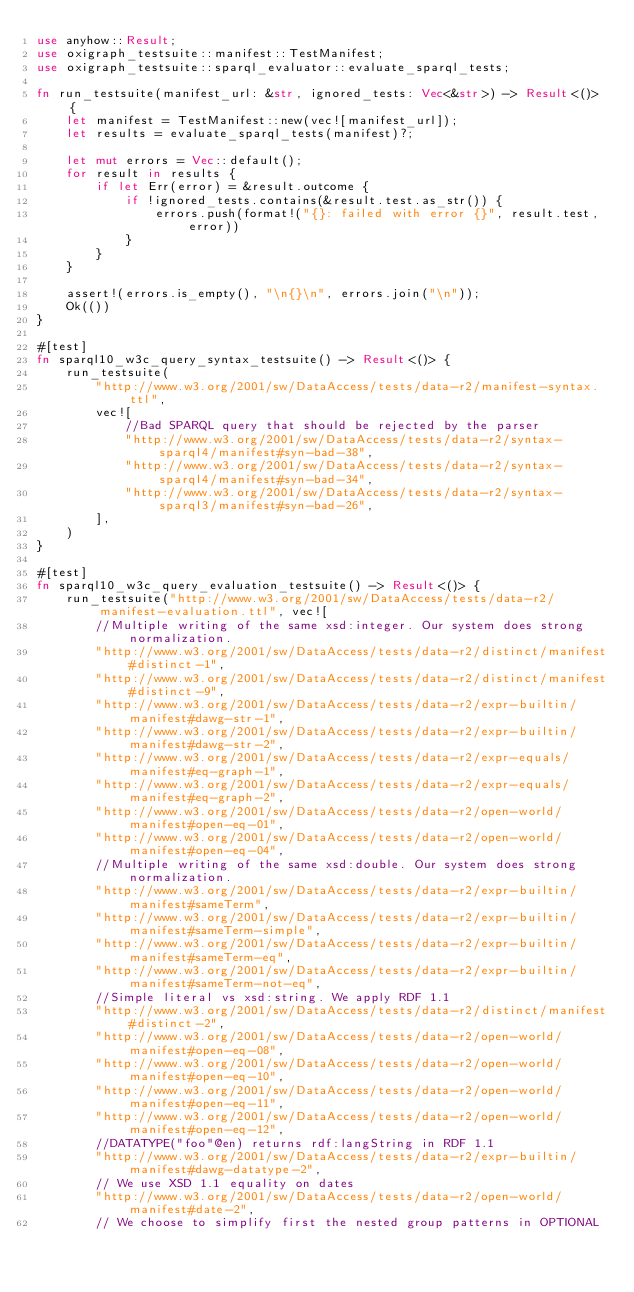<code> <loc_0><loc_0><loc_500><loc_500><_Rust_>use anyhow::Result;
use oxigraph_testsuite::manifest::TestManifest;
use oxigraph_testsuite::sparql_evaluator::evaluate_sparql_tests;

fn run_testsuite(manifest_url: &str, ignored_tests: Vec<&str>) -> Result<()> {
    let manifest = TestManifest::new(vec![manifest_url]);
    let results = evaluate_sparql_tests(manifest)?;

    let mut errors = Vec::default();
    for result in results {
        if let Err(error) = &result.outcome {
            if !ignored_tests.contains(&result.test.as_str()) {
                errors.push(format!("{}: failed with error {}", result.test, error))
            }
        }
    }

    assert!(errors.is_empty(), "\n{}\n", errors.join("\n"));
    Ok(())
}

#[test]
fn sparql10_w3c_query_syntax_testsuite() -> Result<()> {
    run_testsuite(
        "http://www.w3.org/2001/sw/DataAccess/tests/data-r2/manifest-syntax.ttl",
        vec![
            //Bad SPARQL query that should be rejected by the parser
            "http://www.w3.org/2001/sw/DataAccess/tests/data-r2/syntax-sparql4/manifest#syn-bad-38",
            "http://www.w3.org/2001/sw/DataAccess/tests/data-r2/syntax-sparql4/manifest#syn-bad-34",
            "http://www.w3.org/2001/sw/DataAccess/tests/data-r2/syntax-sparql3/manifest#syn-bad-26",
        ],
    )
}

#[test]
fn sparql10_w3c_query_evaluation_testsuite() -> Result<()> {
    run_testsuite("http://www.w3.org/2001/sw/DataAccess/tests/data-r2/manifest-evaluation.ttl", vec![
        //Multiple writing of the same xsd:integer. Our system does strong normalization.
        "http://www.w3.org/2001/sw/DataAccess/tests/data-r2/distinct/manifest#distinct-1",
        "http://www.w3.org/2001/sw/DataAccess/tests/data-r2/distinct/manifest#distinct-9",
        "http://www.w3.org/2001/sw/DataAccess/tests/data-r2/expr-builtin/manifest#dawg-str-1",
        "http://www.w3.org/2001/sw/DataAccess/tests/data-r2/expr-builtin/manifest#dawg-str-2",
        "http://www.w3.org/2001/sw/DataAccess/tests/data-r2/expr-equals/manifest#eq-graph-1",
        "http://www.w3.org/2001/sw/DataAccess/tests/data-r2/expr-equals/manifest#eq-graph-2",
        "http://www.w3.org/2001/sw/DataAccess/tests/data-r2/open-world/manifest#open-eq-01",
        "http://www.w3.org/2001/sw/DataAccess/tests/data-r2/open-world/manifest#open-eq-04",
        //Multiple writing of the same xsd:double. Our system does strong normalization.
        "http://www.w3.org/2001/sw/DataAccess/tests/data-r2/expr-builtin/manifest#sameTerm",
        "http://www.w3.org/2001/sw/DataAccess/tests/data-r2/expr-builtin/manifest#sameTerm-simple",
        "http://www.w3.org/2001/sw/DataAccess/tests/data-r2/expr-builtin/manifest#sameTerm-eq",
        "http://www.w3.org/2001/sw/DataAccess/tests/data-r2/expr-builtin/manifest#sameTerm-not-eq",
        //Simple literal vs xsd:string. We apply RDF 1.1
        "http://www.w3.org/2001/sw/DataAccess/tests/data-r2/distinct/manifest#distinct-2",
        "http://www.w3.org/2001/sw/DataAccess/tests/data-r2/open-world/manifest#open-eq-08",
        "http://www.w3.org/2001/sw/DataAccess/tests/data-r2/open-world/manifest#open-eq-10",
        "http://www.w3.org/2001/sw/DataAccess/tests/data-r2/open-world/manifest#open-eq-11",
        "http://www.w3.org/2001/sw/DataAccess/tests/data-r2/open-world/manifest#open-eq-12",
        //DATATYPE("foo"@en) returns rdf:langString in RDF 1.1
        "http://www.w3.org/2001/sw/DataAccess/tests/data-r2/expr-builtin/manifest#dawg-datatype-2",
        // We use XSD 1.1 equality on dates
        "http://www.w3.org/2001/sw/DataAccess/tests/data-r2/open-world/manifest#date-2",
        // We choose to simplify first the nested group patterns in OPTIONAL</code> 